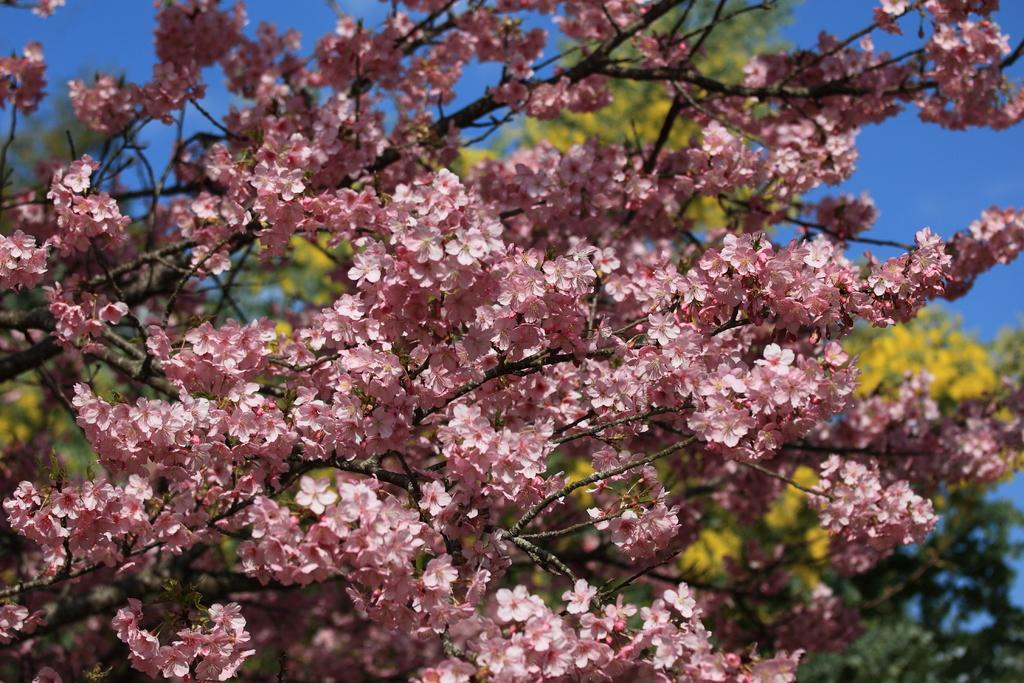What type of vegetation is present in the image? There are trees with flowers in the image. What can be seen in the background of the image? The sky is visible in the background of the image. What type of laborer is working in the field of celery in the image? There is no laborer or field of celery present in the image; it features trees with flowers and a visible sky. How many stars can be seen in the image? There are no stars visible in the image; it only shows trees with flowers and the sky. 